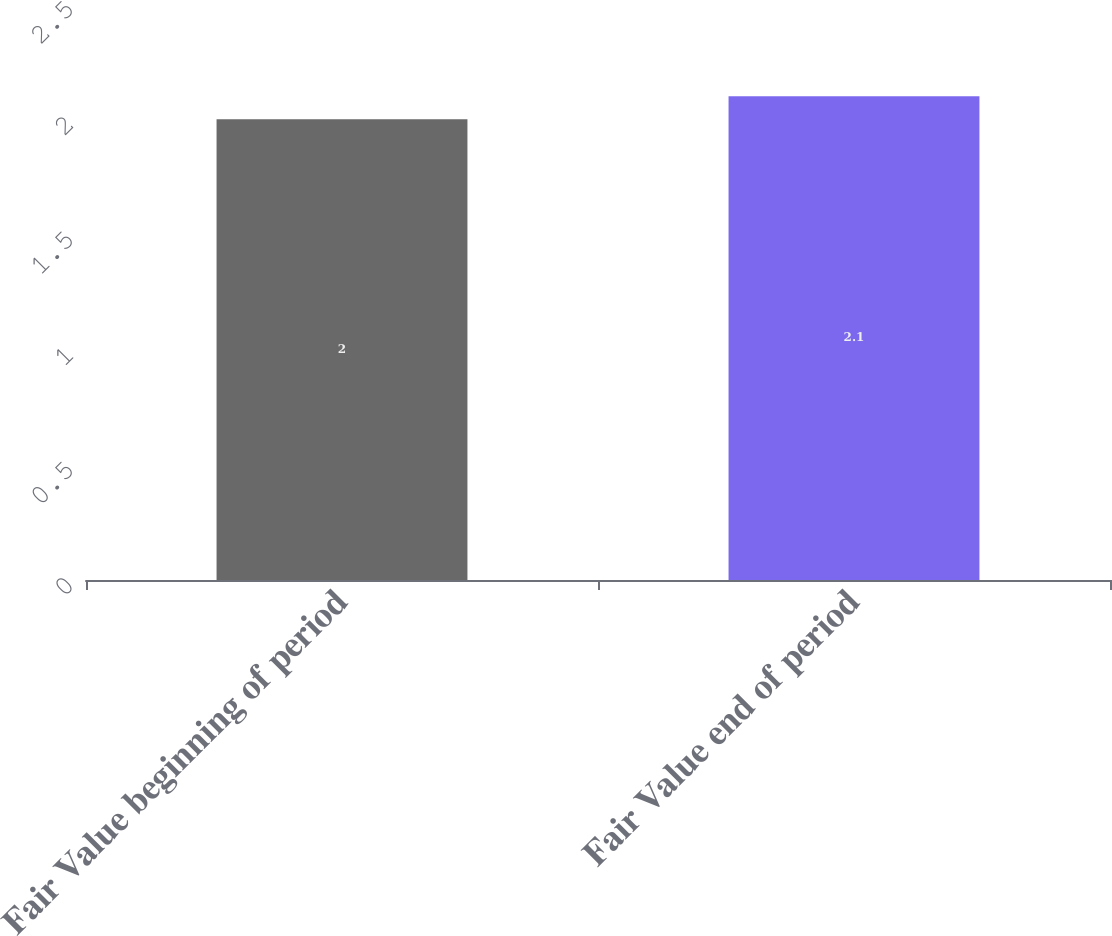Convert chart to OTSL. <chart><loc_0><loc_0><loc_500><loc_500><bar_chart><fcel>Fair Value beginning of period<fcel>Fair Value end of period<nl><fcel>2<fcel>2.1<nl></chart> 